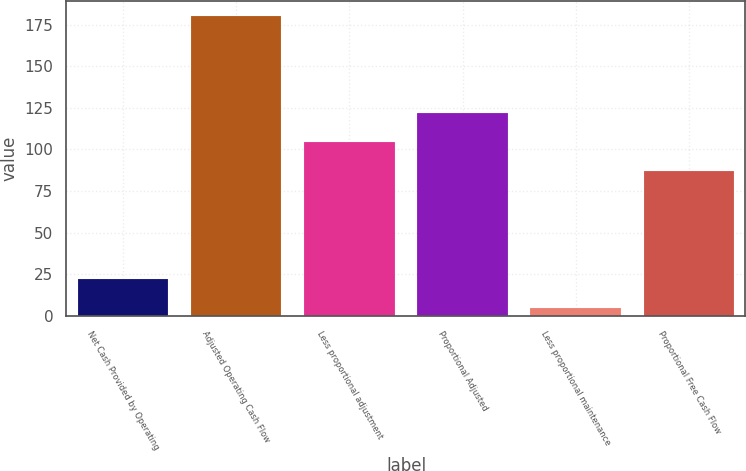<chart> <loc_0><loc_0><loc_500><loc_500><bar_chart><fcel>Net Cash Provided by Operating<fcel>Adjusted Operating Cash Flow<fcel>Less proportional adjustment<fcel>Proportional Adjusted<fcel>Less proportional maintenance<fcel>Proportional Free Cash Flow<nl><fcel>22.5<fcel>180<fcel>104.5<fcel>122<fcel>5<fcel>87<nl></chart> 